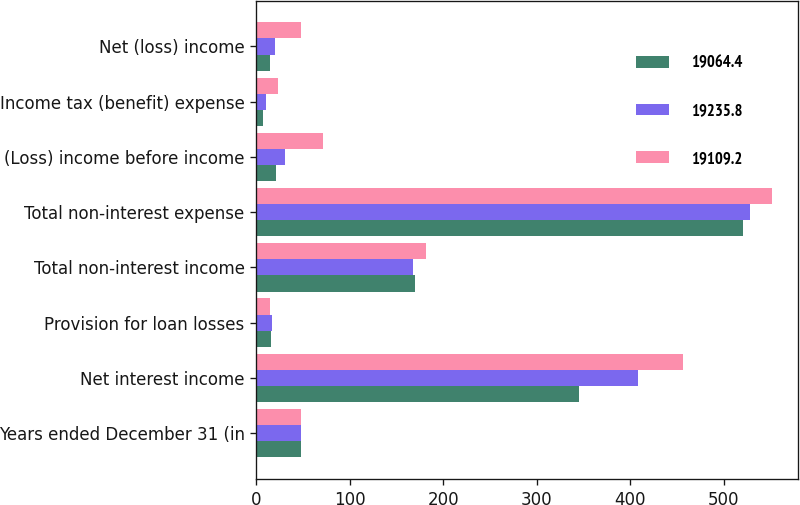<chart> <loc_0><loc_0><loc_500><loc_500><stacked_bar_chart><ecel><fcel>Years ended December 31 (in<fcel>Net interest income<fcel>Provision for loan losses<fcel>Total non-interest income<fcel>Total non-interest expense<fcel>(Loss) income before income<fcel>Income tax (benefit) expense<fcel>Net (loss) income<nl><fcel>19064.4<fcel>47.4<fcel>344.6<fcel>15.2<fcel>169.7<fcel>520.2<fcel>21.1<fcel>7<fcel>14.1<nl><fcel>19235.8<fcel>47.4<fcel>408<fcel>16.8<fcel>167.4<fcel>528<fcel>30.6<fcel>10.3<fcel>20.3<nl><fcel>19109.2<fcel>47.4<fcel>456.3<fcel>15<fcel>180.9<fcel>551.2<fcel>71<fcel>23.6<fcel>47.4<nl></chart> 